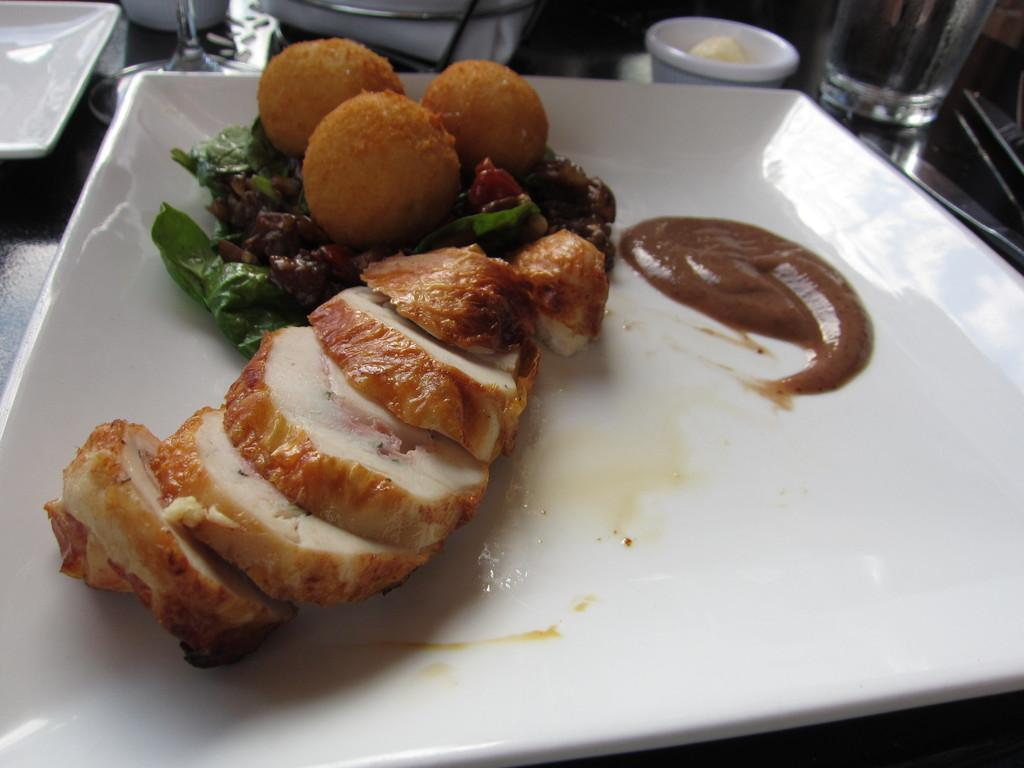What is on the plate that is visible in the image? There is food in a plate in the image. How many plates can be seen in the image? There is another plate visible in the image, making a total of two plates. What is the bowl used for in the image? The bowl is also present in the image, but its purpose is not specified. What is the glass used for in the image? The glass is present in the image, but its purpose is not specified. What utensil is on the table in the image? There is a knife on the table in the image. What type of plant is growing in the glass in the image? There is no plant growing in the glass in the image; it is a glass for holding a liquid. How does the food in the plate make the person feel in the image? The image does not depict a person or their feelings, so it is not possible to determine how the food makes them feel. 